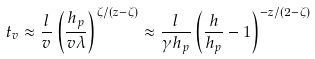<formula> <loc_0><loc_0><loc_500><loc_500>t _ { v } \approx \frac { l } { v } \left ( \frac { h _ { p } } { v \lambda } \right ) ^ { \zeta / ( z - \zeta ) } \approx \frac { l } { \gamma h _ { p } } \left ( \frac { h } { h _ { p } } - 1 \right ) ^ { - z / ( 2 - \zeta ) }</formula> 